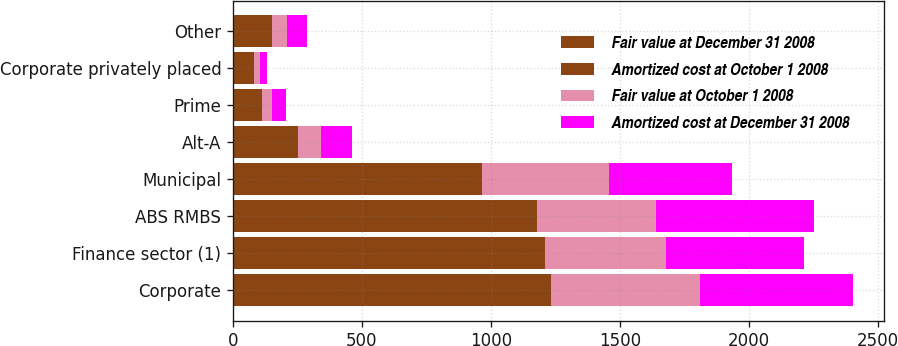Convert chart. <chart><loc_0><loc_0><loc_500><loc_500><stacked_bar_chart><ecel><fcel>Corporate<fcel>Finance sector (1)<fcel>ABS RMBS<fcel>Municipal<fcel>Alt-A<fcel>Prime<fcel>Corporate privately placed<fcel>Other<nl><fcel>Fair value at December 31 2008<fcel>618<fcel>607<fcel>591<fcel>482<fcel>126<fcel>53<fcel>40<fcel>79<nl><fcel>Amortized cost at October 1 2008<fcel>616<fcel>603<fcel>589<fcel>482<fcel>126<fcel>59<fcel>40<fcel>74<nl><fcel>Fair value at October 1 2008<fcel>578<fcel>469<fcel>462<fcel>493<fcel>89<fcel>40<fcel>24<fcel>55<nl><fcel>Amortized cost at December 31 2008<fcel>592<fcel>537<fcel>610<fcel>479<fcel>121<fcel>55<fcel>27<fcel>78<nl></chart> 